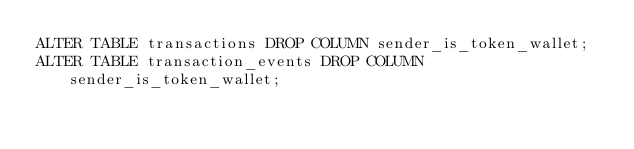<code> <loc_0><loc_0><loc_500><loc_500><_SQL_>ALTER TABLE transactions DROP COLUMN sender_is_token_wallet;
ALTER TABLE transaction_events DROP COLUMN sender_is_token_wallet;
</code> 